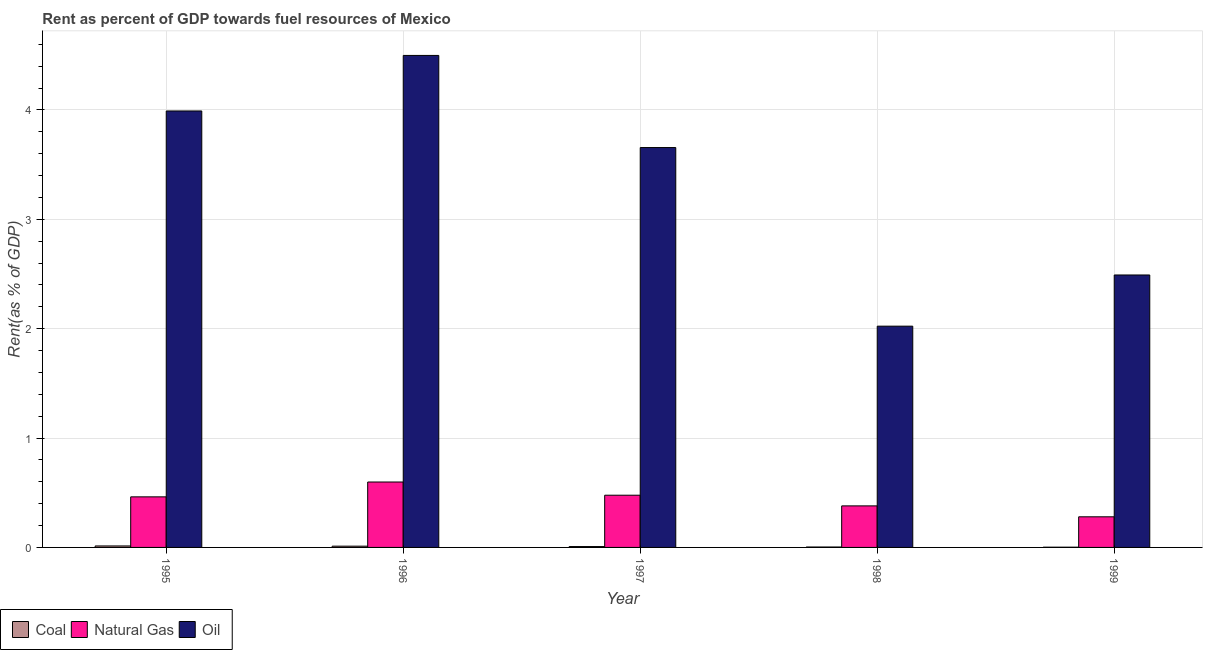How many different coloured bars are there?
Make the answer very short. 3. What is the label of the 3rd group of bars from the left?
Keep it short and to the point. 1997. What is the rent towards oil in 1997?
Keep it short and to the point. 3.66. Across all years, what is the maximum rent towards oil?
Give a very brief answer. 4.5. Across all years, what is the minimum rent towards coal?
Your answer should be compact. 0. What is the total rent towards oil in the graph?
Offer a terse response. 16.66. What is the difference between the rent towards coal in 1998 and that in 1999?
Make the answer very short. 0. What is the difference between the rent towards coal in 1998 and the rent towards natural gas in 1995?
Ensure brevity in your answer.  -0.01. What is the average rent towards oil per year?
Keep it short and to the point. 3.33. What is the ratio of the rent towards oil in 1996 to that in 1999?
Provide a succinct answer. 1.81. Is the rent towards coal in 1995 less than that in 1998?
Keep it short and to the point. No. Is the difference between the rent towards coal in 1996 and 1997 greater than the difference between the rent towards oil in 1996 and 1997?
Keep it short and to the point. No. What is the difference between the highest and the second highest rent towards natural gas?
Your answer should be compact. 0.12. What is the difference between the highest and the lowest rent towards natural gas?
Ensure brevity in your answer.  0.32. Is the sum of the rent towards coal in 1996 and 1997 greater than the maximum rent towards oil across all years?
Provide a succinct answer. Yes. What does the 3rd bar from the left in 1999 represents?
Ensure brevity in your answer.  Oil. What does the 2nd bar from the right in 1997 represents?
Make the answer very short. Natural Gas. How many bars are there?
Provide a succinct answer. 15. How many years are there in the graph?
Give a very brief answer. 5. Does the graph contain grids?
Provide a succinct answer. Yes. How are the legend labels stacked?
Your answer should be compact. Horizontal. What is the title of the graph?
Your response must be concise. Rent as percent of GDP towards fuel resources of Mexico. Does "Manufactures" appear as one of the legend labels in the graph?
Give a very brief answer. No. What is the label or title of the Y-axis?
Your answer should be very brief. Rent(as % of GDP). What is the Rent(as % of GDP) of Coal in 1995?
Your answer should be compact. 0.01. What is the Rent(as % of GDP) of Natural Gas in 1995?
Your response must be concise. 0.46. What is the Rent(as % of GDP) in Oil in 1995?
Your answer should be compact. 3.99. What is the Rent(as % of GDP) in Coal in 1996?
Give a very brief answer. 0.01. What is the Rent(as % of GDP) in Natural Gas in 1996?
Your answer should be compact. 0.6. What is the Rent(as % of GDP) of Oil in 1996?
Provide a short and direct response. 4.5. What is the Rent(as % of GDP) of Coal in 1997?
Make the answer very short. 0.01. What is the Rent(as % of GDP) of Natural Gas in 1997?
Ensure brevity in your answer.  0.48. What is the Rent(as % of GDP) in Oil in 1997?
Offer a terse response. 3.66. What is the Rent(as % of GDP) of Coal in 1998?
Provide a short and direct response. 0. What is the Rent(as % of GDP) of Natural Gas in 1998?
Your answer should be very brief. 0.38. What is the Rent(as % of GDP) of Oil in 1998?
Offer a very short reply. 2.02. What is the Rent(as % of GDP) of Coal in 1999?
Give a very brief answer. 0. What is the Rent(as % of GDP) of Natural Gas in 1999?
Offer a very short reply. 0.28. What is the Rent(as % of GDP) in Oil in 1999?
Provide a short and direct response. 2.49. Across all years, what is the maximum Rent(as % of GDP) in Coal?
Offer a very short reply. 0.01. Across all years, what is the maximum Rent(as % of GDP) of Natural Gas?
Keep it short and to the point. 0.6. Across all years, what is the maximum Rent(as % of GDP) of Oil?
Keep it short and to the point. 4.5. Across all years, what is the minimum Rent(as % of GDP) of Coal?
Give a very brief answer. 0. Across all years, what is the minimum Rent(as % of GDP) in Natural Gas?
Offer a very short reply. 0.28. Across all years, what is the minimum Rent(as % of GDP) in Oil?
Your response must be concise. 2.02. What is the total Rent(as % of GDP) of Coal in the graph?
Your answer should be very brief. 0.04. What is the total Rent(as % of GDP) in Natural Gas in the graph?
Provide a succinct answer. 2.2. What is the total Rent(as % of GDP) of Oil in the graph?
Your answer should be very brief. 16.66. What is the difference between the Rent(as % of GDP) in Coal in 1995 and that in 1996?
Give a very brief answer. 0. What is the difference between the Rent(as % of GDP) of Natural Gas in 1995 and that in 1996?
Your response must be concise. -0.14. What is the difference between the Rent(as % of GDP) of Oil in 1995 and that in 1996?
Keep it short and to the point. -0.51. What is the difference between the Rent(as % of GDP) of Coal in 1995 and that in 1997?
Provide a short and direct response. 0.01. What is the difference between the Rent(as % of GDP) of Natural Gas in 1995 and that in 1997?
Your answer should be very brief. -0.01. What is the difference between the Rent(as % of GDP) in Oil in 1995 and that in 1997?
Make the answer very short. 0.33. What is the difference between the Rent(as % of GDP) in Coal in 1995 and that in 1998?
Give a very brief answer. 0.01. What is the difference between the Rent(as % of GDP) in Natural Gas in 1995 and that in 1998?
Give a very brief answer. 0.08. What is the difference between the Rent(as % of GDP) of Oil in 1995 and that in 1998?
Provide a succinct answer. 1.97. What is the difference between the Rent(as % of GDP) in Coal in 1995 and that in 1999?
Offer a very short reply. 0.01. What is the difference between the Rent(as % of GDP) of Natural Gas in 1995 and that in 1999?
Keep it short and to the point. 0.18. What is the difference between the Rent(as % of GDP) in Oil in 1995 and that in 1999?
Keep it short and to the point. 1.5. What is the difference between the Rent(as % of GDP) of Coal in 1996 and that in 1997?
Provide a short and direct response. 0. What is the difference between the Rent(as % of GDP) of Natural Gas in 1996 and that in 1997?
Your answer should be compact. 0.12. What is the difference between the Rent(as % of GDP) in Oil in 1996 and that in 1997?
Ensure brevity in your answer.  0.84. What is the difference between the Rent(as % of GDP) in Coal in 1996 and that in 1998?
Offer a very short reply. 0.01. What is the difference between the Rent(as % of GDP) in Natural Gas in 1996 and that in 1998?
Provide a short and direct response. 0.22. What is the difference between the Rent(as % of GDP) in Oil in 1996 and that in 1998?
Offer a very short reply. 2.48. What is the difference between the Rent(as % of GDP) in Coal in 1996 and that in 1999?
Offer a terse response. 0.01. What is the difference between the Rent(as % of GDP) of Natural Gas in 1996 and that in 1999?
Your answer should be compact. 0.32. What is the difference between the Rent(as % of GDP) of Oil in 1996 and that in 1999?
Ensure brevity in your answer.  2.01. What is the difference between the Rent(as % of GDP) in Coal in 1997 and that in 1998?
Provide a succinct answer. 0. What is the difference between the Rent(as % of GDP) of Natural Gas in 1997 and that in 1998?
Offer a very short reply. 0.1. What is the difference between the Rent(as % of GDP) in Oil in 1997 and that in 1998?
Ensure brevity in your answer.  1.63. What is the difference between the Rent(as % of GDP) of Coal in 1997 and that in 1999?
Provide a short and direct response. 0.01. What is the difference between the Rent(as % of GDP) of Natural Gas in 1997 and that in 1999?
Offer a terse response. 0.2. What is the difference between the Rent(as % of GDP) of Oil in 1997 and that in 1999?
Make the answer very short. 1.17. What is the difference between the Rent(as % of GDP) of Coal in 1998 and that in 1999?
Ensure brevity in your answer.  0. What is the difference between the Rent(as % of GDP) of Natural Gas in 1998 and that in 1999?
Make the answer very short. 0.1. What is the difference between the Rent(as % of GDP) in Oil in 1998 and that in 1999?
Ensure brevity in your answer.  -0.47. What is the difference between the Rent(as % of GDP) of Coal in 1995 and the Rent(as % of GDP) of Natural Gas in 1996?
Your answer should be compact. -0.58. What is the difference between the Rent(as % of GDP) of Coal in 1995 and the Rent(as % of GDP) of Oil in 1996?
Your answer should be compact. -4.49. What is the difference between the Rent(as % of GDP) in Natural Gas in 1995 and the Rent(as % of GDP) in Oil in 1996?
Your response must be concise. -4.04. What is the difference between the Rent(as % of GDP) of Coal in 1995 and the Rent(as % of GDP) of Natural Gas in 1997?
Make the answer very short. -0.46. What is the difference between the Rent(as % of GDP) of Coal in 1995 and the Rent(as % of GDP) of Oil in 1997?
Your response must be concise. -3.64. What is the difference between the Rent(as % of GDP) of Natural Gas in 1995 and the Rent(as % of GDP) of Oil in 1997?
Your answer should be very brief. -3.19. What is the difference between the Rent(as % of GDP) in Coal in 1995 and the Rent(as % of GDP) in Natural Gas in 1998?
Provide a short and direct response. -0.37. What is the difference between the Rent(as % of GDP) of Coal in 1995 and the Rent(as % of GDP) of Oil in 1998?
Offer a very short reply. -2.01. What is the difference between the Rent(as % of GDP) in Natural Gas in 1995 and the Rent(as % of GDP) in Oil in 1998?
Provide a short and direct response. -1.56. What is the difference between the Rent(as % of GDP) in Coal in 1995 and the Rent(as % of GDP) in Natural Gas in 1999?
Your answer should be compact. -0.27. What is the difference between the Rent(as % of GDP) of Coal in 1995 and the Rent(as % of GDP) of Oil in 1999?
Provide a short and direct response. -2.48. What is the difference between the Rent(as % of GDP) in Natural Gas in 1995 and the Rent(as % of GDP) in Oil in 1999?
Ensure brevity in your answer.  -2.03. What is the difference between the Rent(as % of GDP) of Coal in 1996 and the Rent(as % of GDP) of Natural Gas in 1997?
Keep it short and to the point. -0.47. What is the difference between the Rent(as % of GDP) of Coal in 1996 and the Rent(as % of GDP) of Oil in 1997?
Your response must be concise. -3.64. What is the difference between the Rent(as % of GDP) in Natural Gas in 1996 and the Rent(as % of GDP) in Oil in 1997?
Make the answer very short. -3.06. What is the difference between the Rent(as % of GDP) of Coal in 1996 and the Rent(as % of GDP) of Natural Gas in 1998?
Your answer should be compact. -0.37. What is the difference between the Rent(as % of GDP) in Coal in 1996 and the Rent(as % of GDP) in Oil in 1998?
Provide a succinct answer. -2.01. What is the difference between the Rent(as % of GDP) in Natural Gas in 1996 and the Rent(as % of GDP) in Oil in 1998?
Offer a terse response. -1.43. What is the difference between the Rent(as % of GDP) of Coal in 1996 and the Rent(as % of GDP) of Natural Gas in 1999?
Offer a terse response. -0.27. What is the difference between the Rent(as % of GDP) of Coal in 1996 and the Rent(as % of GDP) of Oil in 1999?
Provide a succinct answer. -2.48. What is the difference between the Rent(as % of GDP) of Natural Gas in 1996 and the Rent(as % of GDP) of Oil in 1999?
Your response must be concise. -1.89. What is the difference between the Rent(as % of GDP) of Coal in 1997 and the Rent(as % of GDP) of Natural Gas in 1998?
Give a very brief answer. -0.37. What is the difference between the Rent(as % of GDP) in Coal in 1997 and the Rent(as % of GDP) in Oil in 1998?
Offer a terse response. -2.02. What is the difference between the Rent(as % of GDP) of Natural Gas in 1997 and the Rent(as % of GDP) of Oil in 1998?
Offer a very short reply. -1.55. What is the difference between the Rent(as % of GDP) of Coal in 1997 and the Rent(as % of GDP) of Natural Gas in 1999?
Ensure brevity in your answer.  -0.27. What is the difference between the Rent(as % of GDP) of Coal in 1997 and the Rent(as % of GDP) of Oil in 1999?
Your answer should be very brief. -2.48. What is the difference between the Rent(as % of GDP) of Natural Gas in 1997 and the Rent(as % of GDP) of Oil in 1999?
Your answer should be compact. -2.01. What is the difference between the Rent(as % of GDP) in Coal in 1998 and the Rent(as % of GDP) in Natural Gas in 1999?
Offer a terse response. -0.28. What is the difference between the Rent(as % of GDP) of Coal in 1998 and the Rent(as % of GDP) of Oil in 1999?
Your response must be concise. -2.49. What is the difference between the Rent(as % of GDP) in Natural Gas in 1998 and the Rent(as % of GDP) in Oil in 1999?
Ensure brevity in your answer.  -2.11. What is the average Rent(as % of GDP) in Coal per year?
Your response must be concise. 0.01. What is the average Rent(as % of GDP) in Natural Gas per year?
Offer a terse response. 0.44. What is the average Rent(as % of GDP) of Oil per year?
Give a very brief answer. 3.33. In the year 1995, what is the difference between the Rent(as % of GDP) of Coal and Rent(as % of GDP) of Natural Gas?
Keep it short and to the point. -0.45. In the year 1995, what is the difference between the Rent(as % of GDP) in Coal and Rent(as % of GDP) in Oil?
Make the answer very short. -3.98. In the year 1995, what is the difference between the Rent(as % of GDP) in Natural Gas and Rent(as % of GDP) in Oil?
Ensure brevity in your answer.  -3.53. In the year 1996, what is the difference between the Rent(as % of GDP) of Coal and Rent(as % of GDP) of Natural Gas?
Keep it short and to the point. -0.59. In the year 1996, what is the difference between the Rent(as % of GDP) of Coal and Rent(as % of GDP) of Oil?
Give a very brief answer. -4.49. In the year 1996, what is the difference between the Rent(as % of GDP) of Natural Gas and Rent(as % of GDP) of Oil?
Your answer should be compact. -3.9. In the year 1997, what is the difference between the Rent(as % of GDP) of Coal and Rent(as % of GDP) of Natural Gas?
Offer a terse response. -0.47. In the year 1997, what is the difference between the Rent(as % of GDP) in Coal and Rent(as % of GDP) in Oil?
Your answer should be very brief. -3.65. In the year 1997, what is the difference between the Rent(as % of GDP) in Natural Gas and Rent(as % of GDP) in Oil?
Offer a very short reply. -3.18. In the year 1998, what is the difference between the Rent(as % of GDP) of Coal and Rent(as % of GDP) of Natural Gas?
Make the answer very short. -0.38. In the year 1998, what is the difference between the Rent(as % of GDP) of Coal and Rent(as % of GDP) of Oil?
Offer a very short reply. -2.02. In the year 1998, what is the difference between the Rent(as % of GDP) of Natural Gas and Rent(as % of GDP) of Oil?
Offer a terse response. -1.64. In the year 1999, what is the difference between the Rent(as % of GDP) in Coal and Rent(as % of GDP) in Natural Gas?
Provide a short and direct response. -0.28. In the year 1999, what is the difference between the Rent(as % of GDP) of Coal and Rent(as % of GDP) of Oil?
Keep it short and to the point. -2.49. In the year 1999, what is the difference between the Rent(as % of GDP) of Natural Gas and Rent(as % of GDP) of Oil?
Your answer should be very brief. -2.21. What is the ratio of the Rent(as % of GDP) of Coal in 1995 to that in 1996?
Give a very brief answer. 1.18. What is the ratio of the Rent(as % of GDP) in Natural Gas in 1995 to that in 1996?
Offer a terse response. 0.77. What is the ratio of the Rent(as % of GDP) of Oil in 1995 to that in 1996?
Your answer should be very brief. 0.89. What is the ratio of the Rent(as % of GDP) in Coal in 1995 to that in 1997?
Provide a succinct answer. 1.71. What is the ratio of the Rent(as % of GDP) in Natural Gas in 1995 to that in 1997?
Offer a very short reply. 0.97. What is the ratio of the Rent(as % of GDP) in Oil in 1995 to that in 1997?
Your answer should be very brief. 1.09. What is the ratio of the Rent(as % of GDP) in Coal in 1995 to that in 1998?
Provide a succinct answer. 3.52. What is the ratio of the Rent(as % of GDP) in Natural Gas in 1995 to that in 1998?
Your answer should be very brief. 1.22. What is the ratio of the Rent(as % of GDP) in Oil in 1995 to that in 1998?
Offer a very short reply. 1.97. What is the ratio of the Rent(as % of GDP) of Coal in 1995 to that in 1999?
Make the answer very short. 6.58. What is the ratio of the Rent(as % of GDP) in Natural Gas in 1995 to that in 1999?
Your response must be concise. 1.65. What is the ratio of the Rent(as % of GDP) of Oil in 1995 to that in 1999?
Make the answer very short. 1.6. What is the ratio of the Rent(as % of GDP) of Coal in 1996 to that in 1997?
Your answer should be very brief. 1.45. What is the ratio of the Rent(as % of GDP) of Natural Gas in 1996 to that in 1997?
Your answer should be compact. 1.25. What is the ratio of the Rent(as % of GDP) in Oil in 1996 to that in 1997?
Provide a short and direct response. 1.23. What is the ratio of the Rent(as % of GDP) in Coal in 1996 to that in 1998?
Give a very brief answer. 3. What is the ratio of the Rent(as % of GDP) of Natural Gas in 1996 to that in 1998?
Offer a terse response. 1.57. What is the ratio of the Rent(as % of GDP) in Oil in 1996 to that in 1998?
Give a very brief answer. 2.22. What is the ratio of the Rent(as % of GDP) in Coal in 1996 to that in 1999?
Your answer should be compact. 5.59. What is the ratio of the Rent(as % of GDP) in Natural Gas in 1996 to that in 1999?
Ensure brevity in your answer.  2.14. What is the ratio of the Rent(as % of GDP) in Oil in 1996 to that in 1999?
Your answer should be compact. 1.81. What is the ratio of the Rent(as % of GDP) of Coal in 1997 to that in 1998?
Offer a terse response. 2.06. What is the ratio of the Rent(as % of GDP) of Natural Gas in 1997 to that in 1998?
Your response must be concise. 1.26. What is the ratio of the Rent(as % of GDP) of Oil in 1997 to that in 1998?
Your response must be concise. 1.81. What is the ratio of the Rent(as % of GDP) in Coal in 1997 to that in 1999?
Give a very brief answer. 3.85. What is the ratio of the Rent(as % of GDP) in Natural Gas in 1997 to that in 1999?
Make the answer very short. 1.71. What is the ratio of the Rent(as % of GDP) in Oil in 1997 to that in 1999?
Provide a succinct answer. 1.47. What is the ratio of the Rent(as % of GDP) of Coal in 1998 to that in 1999?
Offer a terse response. 1.87. What is the ratio of the Rent(as % of GDP) in Natural Gas in 1998 to that in 1999?
Ensure brevity in your answer.  1.36. What is the ratio of the Rent(as % of GDP) in Oil in 1998 to that in 1999?
Make the answer very short. 0.81. What is the difference between the highest and the second highest Rent(as % of GDP) in Coal?
Offer a terse response. 0. What is the difference between the highest and the second highest Rent(as % of GDP) in Natural Gas?
Give a very brief answer. 0.12. What is the difference between the highest and the second highest Rent(as % of GDP) in Oil?
Your response must be concise. 0.51. What is the difference between the highest and the lowest Rent(as % of GDP) of Coal?
Your answer should be compact. 0.01. What is the difference between the highest and the lowest Rent(as % of GDP) of Natural Gas?
Keep it short and to the point. 0.32. What is the difference between the highest and the lowest Rent(as % of GDP) in Oil?
Keep it short and to the point. 2.48. 